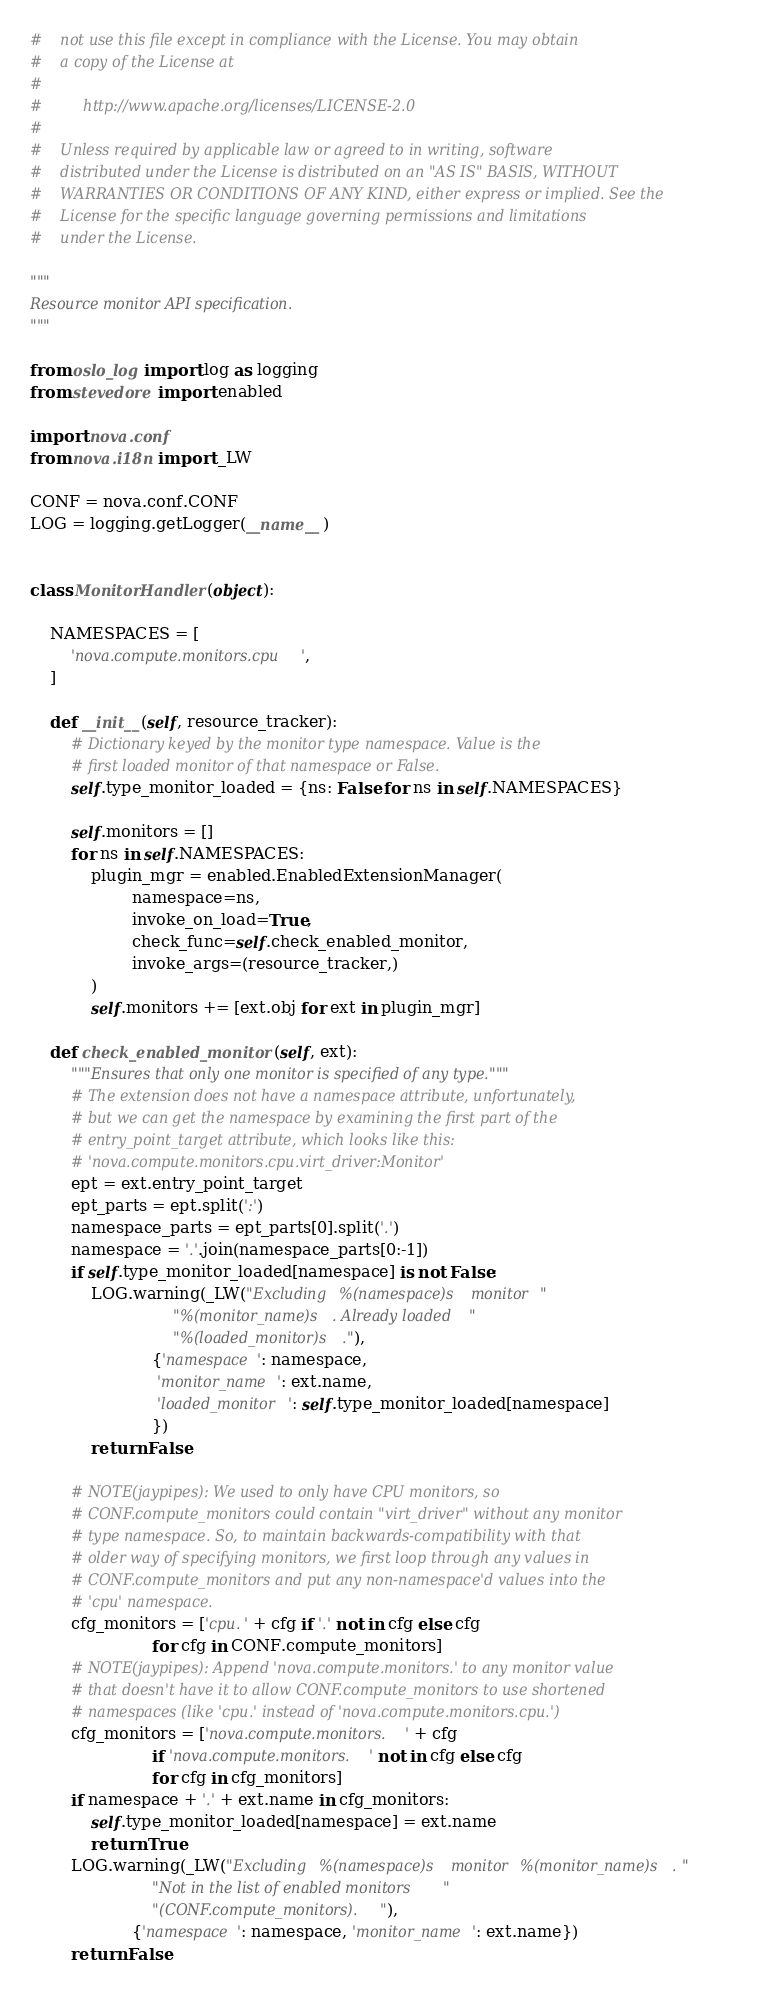<code> <loc_0><loc_0><loc_500><loc_500><_Python_>#    not use this file except in compliance with the License. You may obtain
#    a copy of the License at
#
#         http://www.apache.org/licenses/LICENSE-2.0
#
#    Unless required by applicable law or agreed to in writing, software
#    distributed under the License is distributed on an "AS IS" BASIS, WITHOUT
#    WARRANTIES OR CONDITIONS OF ANY KIND, either express or implied. See the
#    License for the specific language governing permissions and limitations
#    under the License.

"""
Resource monitor API specification.
"""

from oslo_log import log as logging
from stevedore import enabled

import nova.conf
from nova.i18n import _LW

CONF = nova.conf.CONF
LOG = logging.getLogger(__name__)


class MonitorHandler(object):

    NAMESPACES = [
        'nova.compute.monitors.cpu',
    ]

    def __init__(self, resource_tracker):
        # Dictionary keyed by the monitor type namespace. Value is the
        # first loaded monitor of that namespace or False.
        self.type_monitor_loaded = {ns: False for ns in self.NAMESPACES}

        self.monitors = []
        for ns in self.NAMESPACES:
            plugin_mgr = enabled.EnabledExtensionManager(
                    namespace=ns,
                    invoke_on_load=True,
                    check_func=self.check_enabled_monitor,
                    invoke_args=(resource_tracker,)
            )
            self.monitors += [ext.obj for ext in plugin_mgr]

    def check_enabled_monitor(self, ext):
        """Ensures that only one monitor is specified of any type."""
        # The extension does not have a namespace attribute, unfortunately,
        # but we can get the namespace by examining the first part of the
        # entry_point_target attribute, which looks like this:
        # 'nova.compute.monitors.cpu.virt_driver:Monitor'
        ept = ext.entry_point_target
        ept_parts = ept.split(':')
        namespace_parts = ept_parts[0].split('.')
        namespace = '.'.join(namespace_parts[0:-1])
        if self.type_monitor_loaded[namespace] is not False:
            LOG.warning(_LW("Excluding %(namespace)s monitor "
                            "%(monitor_name)s. Already loaded "
                            "%(loaded_monitor)s."),
                        {'namespace': namespace,
                         'monitor_name': ext.name,
                         'loaded_monitor': self.type_monitor_loaded[namespace]
                        })
            return False

        # NOTE(jaypipes): We used to only have CPU monitors, so
        # CONF.compute_monitors could contain "virt_driver" without any monitor
        # type namespace. So, to maintain backwards-compatibility with that
        # older way of specifying monitors, we first loop through any values in
        # CONF.compute_monitors and put any non-namespace'd values into the
        # 'cpu' namespace.
        cfg_monitors = ['cpu.' + cfg if '.' not in cfg else cfg
                        for cfg in CONF.compute_monitors]
        # NOTE(jaypipes): Append 'nova.compute.monitors.' to any monitor value
        # that doesn't have it to allow CONF.compute_monitors to use shortened
        # namespaces (like 'cpu.' instead of 'nova.compute.monitors.cpu.')
        cfg_monitors = ['nova.compute.monitors.' + cfg
                        if 'nova.compute.monitors.' not in cfg else cfg
                        for cfg in cfg_monitors]
        if namespace + '.' + ext.name in cfg_monitors:
            self.type_monitor_loaded[namespace] = ext.name
            return True
        LOG.warning(_LW("Excluding %(namespace)s monitor %(monitor_name)s. "
                        "Not in the list of enabled monitors "
                        "(CONF.compute_monitors)."),
                    {'namespace': namespace, 'monitor_name': ext.name})
        return False
</code> 